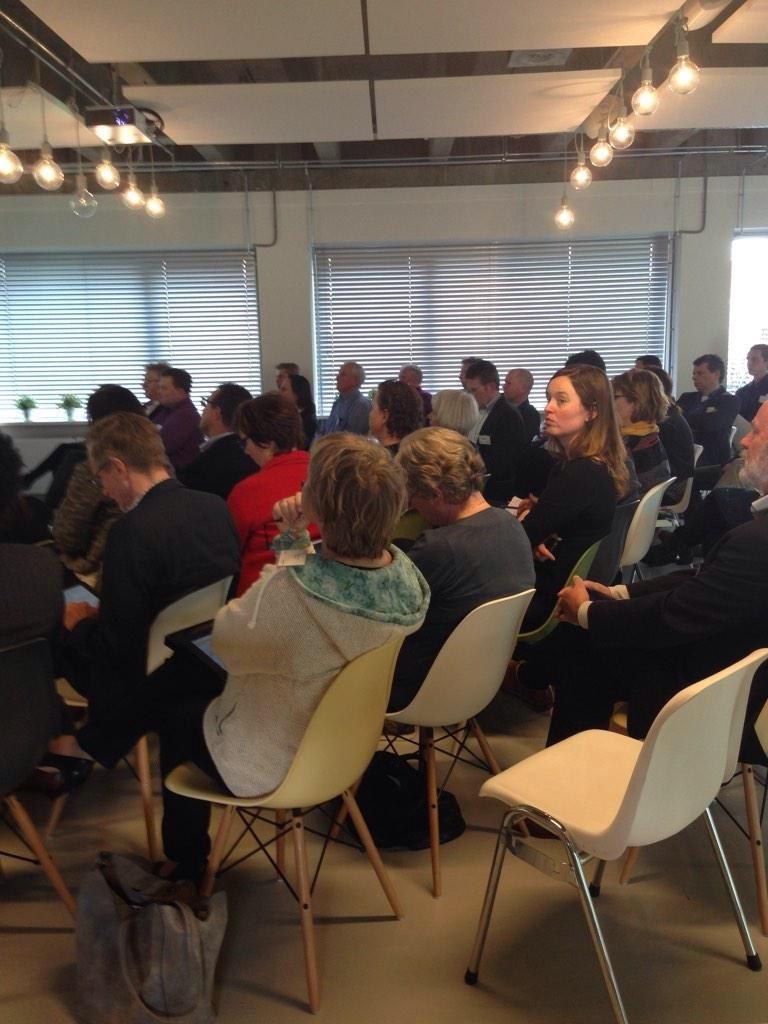Describe this image in one or two sentences. This picture is clicked inside a room. There a people sitting on chairs. At the below left corner there is bag beside the chair. There are bulbs hanging through the ceiling. In the background there is wall, window blinds and small plants. 